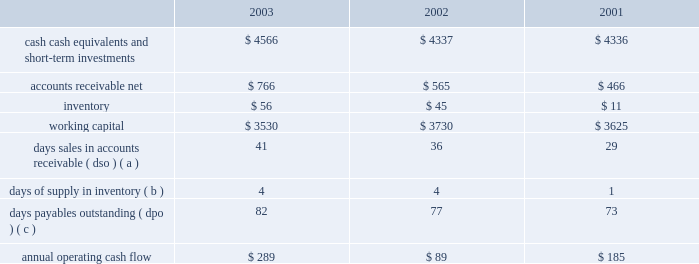30 of 93 liquidity and capital resources the table presents selected financial information and statistics for each of the last three fiscal years ( dollars in millions ) : .
( a ) dso is based on ending net trade receivables and most recent quarterly net sales for each period .
( b ) days supply of inventory is based on ending inventory and most recent quarterly cost of sales for each period .
( c ) dpo is based on ending accounts payable and most recent quarterly cost of sales adjusted for the change in inventory .
As of september 27 , 2003 , the company 2019s cash , cash equivalents , and short-term investments portfolio totaled $ 4.566 billion , an increase of $ 229 million from the end of fiscal 2002 .
The company 2019s short-term investment portfolio consists primarily of investments in u.s .
Treasury and agency securities , u.s .
Corporate securities , and foreign securities .
Foreign securities consist primarily of foreign commercial paper , certificates of deposit and time deposits with foreign institutions , most of which are denominated in u.s .
Dollars .
The company 2019s investments are generally liquid and investment grade .
As a result of declining investment yields on the company 2019s cash equivalents and short-term investments resulting from substantially lower market interest rates during 2003 , the company has elected to reduce the average maturity of its portfolio to maintain liquidity for future investment opportunities when market interest rates increase .
Accordingly , during 2003 the company increased its holdings in short-term investment grade instruments , both in u.s .
Corporate and foreign securities , that are classified as cash equivalents and has reduced its holdings in longer-term u.s .
Corporate securities classified as short-term investments .
Although the company 2019s cash , cash equivalents , and short-term investments increased in 2003 , the company 2019s working capital at september 27 , 2003 decreased by $ 200 million as compared to the end of fiscal 2002 due primarily to the current year reclassification of the company 2019s long-term debt as a current obligation resulting from its scheduled maturity in february 2004 .
The primary sources of total cash and cash equivalents in fiscal 2003 were $ 289 million in cash generated by operating activities and $ 53 million in proceeds from the issuance of common stock , partially offset by $ 164 million utilized for capital expenditures and $ 26 million for the repurchase of common stock .
The company believes its existing balances of cash , cash equivalents , and short-term investments will be sufficient to satisfy its working capital needs , capital expenditures , debt obligations , stock repurchase activity , outstanding commitments , and other liquidity requirements associated with its existing operations over the next 12 months .
The company currently has debt outstanding in the form of $ 300 million of aggregate principal amount 6.5% ( 6.5 % ) unsecured notes that were originally issued in 1994 .
The notes , which pay interest semiannually , were sold at 99.925% ( 99.925 % ) of par , for an effective yield to maturity of 6.51% ( 6.51 % ) .
The notes , along with approximately $ 4 million of unamortized deferred gains on closed interest rate swaps , are due in february 2004 and therefore have been classified as current debt as of september 27 , 2003 .
The company currently anticipates utilizing its existing cash balances to settle these notes when due .
Capital expenditures the company 2019s total capital expenditures were $ 164 million during fiscal 2003 , $ 92 million of which were for retail store facilities and equipment related to the company 2019s retail segment and $ 72 million of which were primarily for corporate infrastructure , including information systems enhancements and operating facilities enhancements and expansions .
The company currently anticipates it will utilize approximately $ 160 million for capital expenditures during 2004 , approximately $ 85 million of which is expected to be utilized for further expansion of the company 2019s retail segment and the remainder utilized to support normal replacement of existing capital assets and enhancements to general information technology infrastructure .
Stock repurchase plan in july 1999 , the company's board of directors authorized a plan for the company to repurchase up to $ 500 million of its common stock .
This repurchase plan does not obligate the company to acquire any specific number of shares or acquire shares over any specified period of time. .
What was the largest annual operating cash flow , in millions? 
Computations: table_max(annual operating cash flow, none)
Answer: 289.0. 